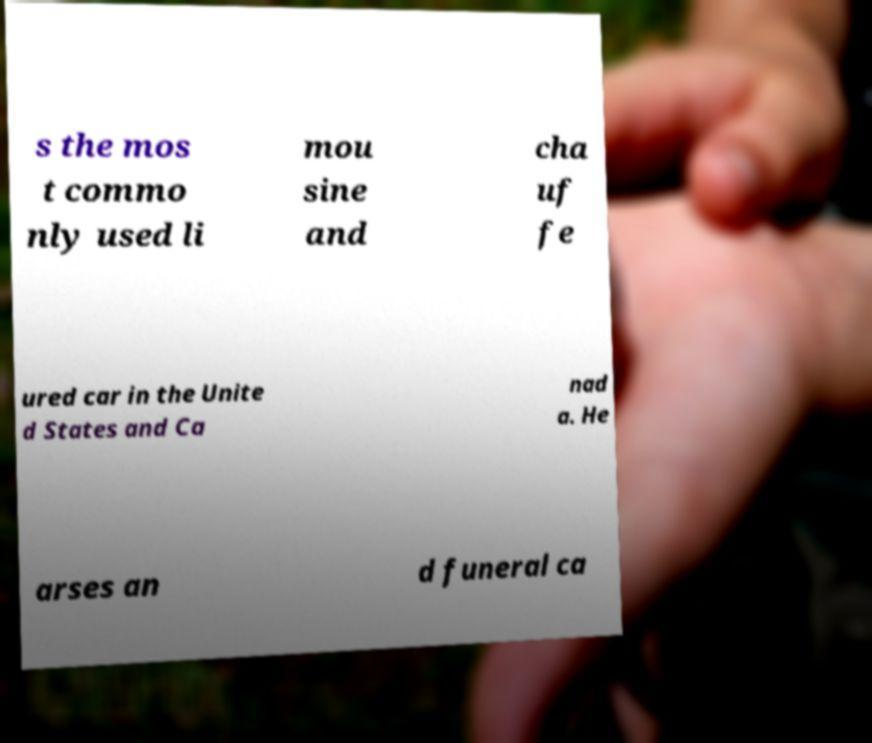What messages or text are displayed in this image? I need them in a readable, typed format. s the mos t commo nly used li mou sine and cha uf fe ured car in the Unite d States and Ca nad a. He arses an d funeral ca 